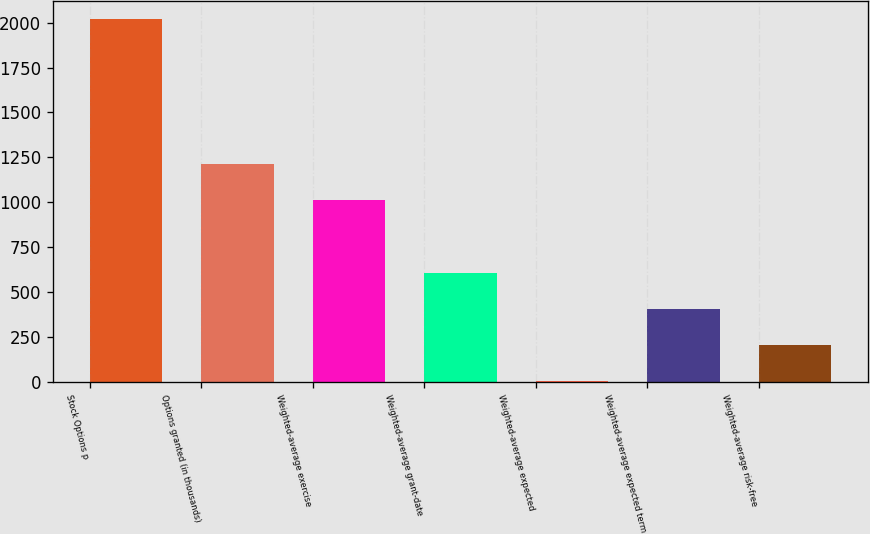Convert chart. <chart><loc_0><loc_0><loc_500><loc_500><bar_chart><fcel>Stock Options p<fcel>Options granted (in thousands)<fcel>Weighted-average exercise<fcel>Weighted-average grant-date<fcel>Weighted-average expected<fcel>Weighted-average expected term<fcel>Weighted-average risk-free<nl><fcel>2019<fcel>1212.2<fcel>1010.5<fcel>607.1<fcel>2<fcel>405.4<fcel>203.7<nl></chart> 